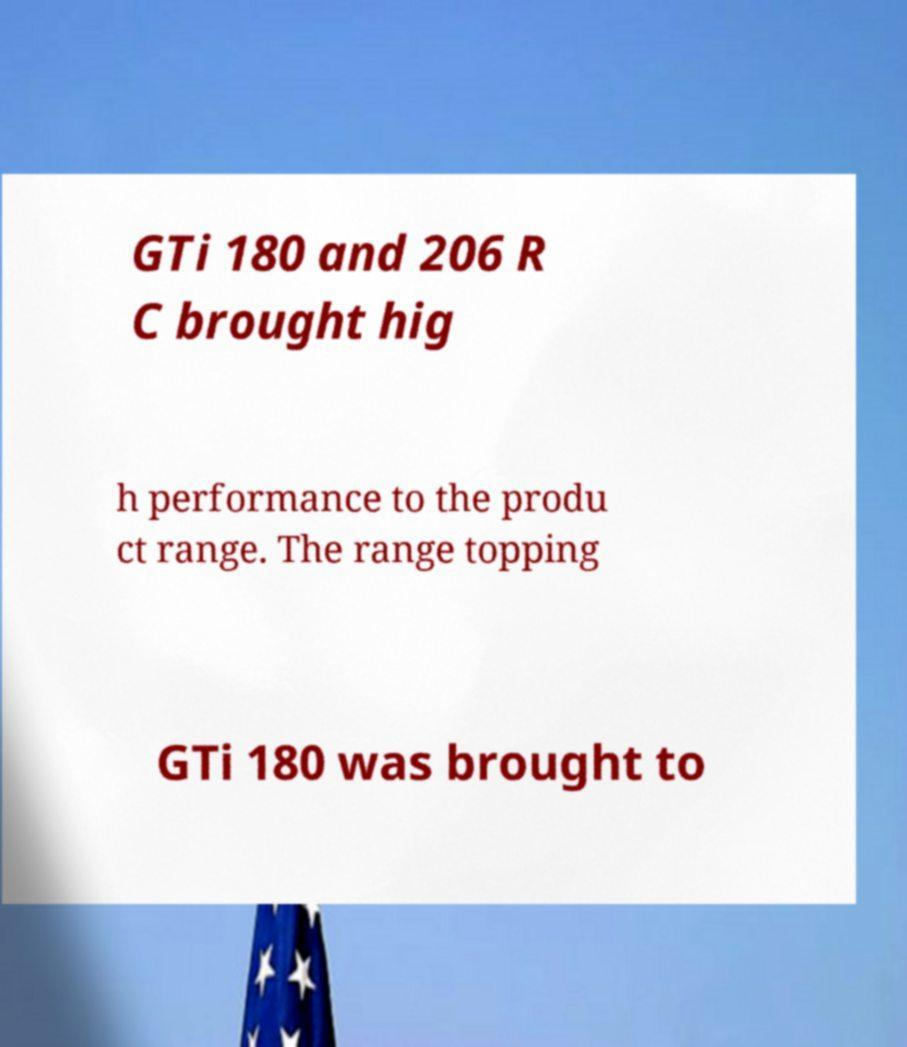Can you accurately transcribe the text from the provided image for me? GTi 180 and 206 R C brought hig h performance to the produ ct range. The range topping GTi 180 was brought to 